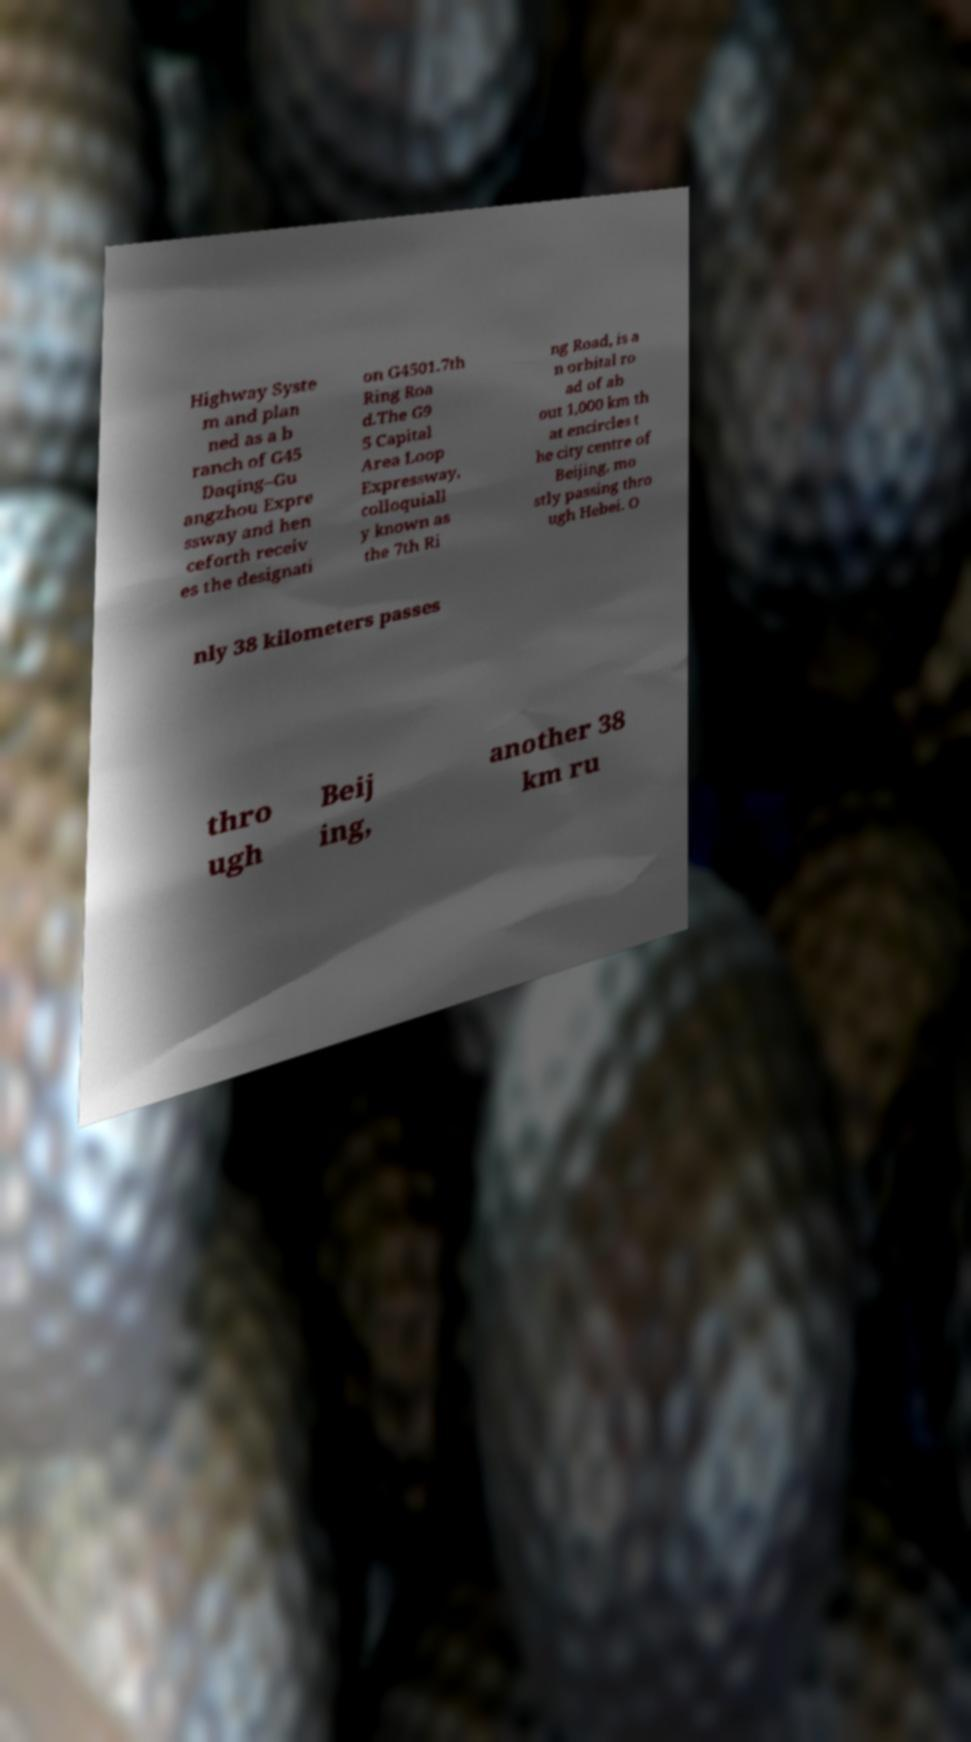Could you extract and type out the text from this image? Highway Syste m and plan ned as a b ranch of G45 Daqing–Gu angzhou Expre ssway and hen ceforth receiv es the designati on G4501.7th Ring Roa d.The G9 5 Capital Area Loop Expressway, colloquiall y known as the 7th Ri ng Road, is a n orbital ro ad of ab out 1,000 km th at encircles t he city centre of Beijing, mo stly passing thro ugh Hebei. O nly 38 kilometers passes thro ugh Beij ing, another 38 km ru 